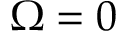<formula> <loc_0><loc_0><loc_500><loc_500>\Omega = 0</formula> 